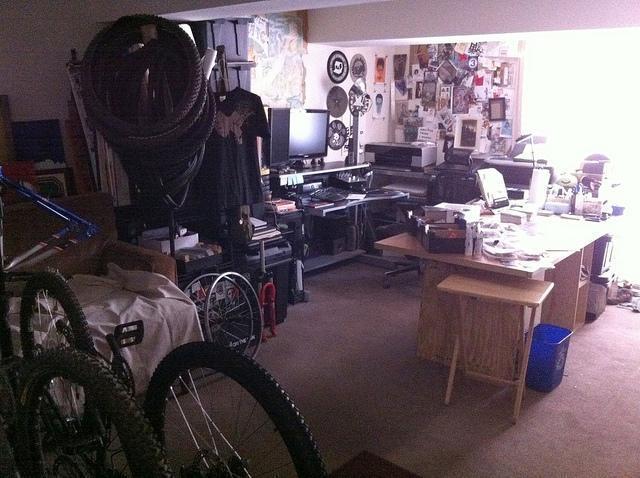How many bicycles are in the picture?
Give a very brief answer. 2. 